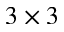<formula> <loc_0><loc_0><loc_500><loc_500>3 \times 3</formula> 